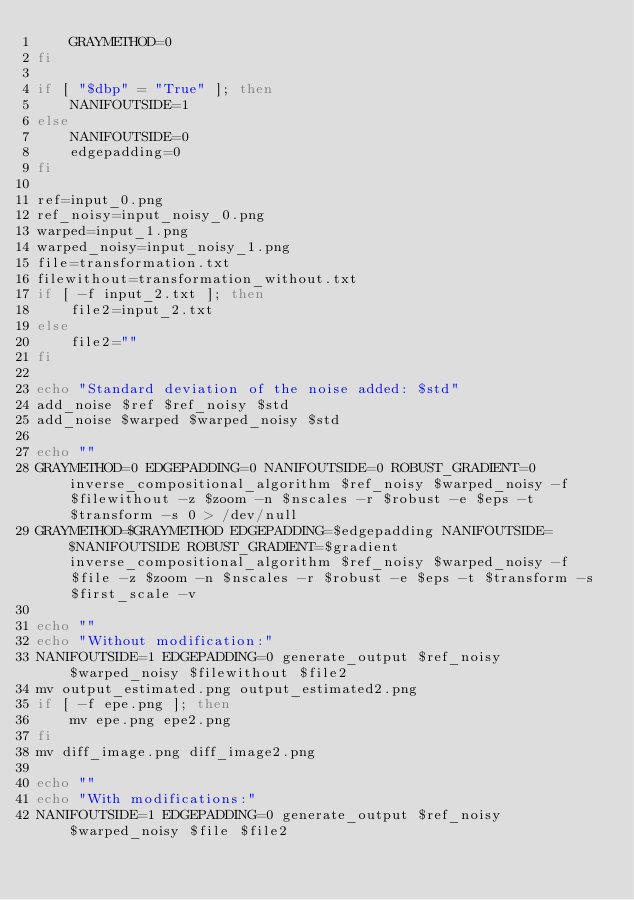Convert code to text. <code><loc_0><loc_0><loc_500><loc_500><_Bash_>    GRAYMETHOD=0
fi

if [ "$dbp" = "True" ]; then
    NANIFOUTSIDE=1
else
    NANIFOUTSIDE=0
    edgepadding=0
fi

ref=input_0.png
ref_noisy=input_noisy_0.png
warped=input_1.png
warped_noisy=input_noisy_1.png
file=transformation.txt
filewithout=transformation_without.txt
if [ -f input_2.txt ]; then
    file2=input_2.txt
else
    file2=""
fi

echo "Standard deviation of the noise added: $std"
add_noise $ref $ref_noisy $std
add_noise $warped $warped_noisy $std

echo ""
GRAYMETHOD=0 EDGEPADDING=0 NANIFOUTSIDE=0 ROBUST_GRADIENT=0 inverse_compositional_algorithm $ref_noisy $warped_noisy -f $filewithout -z $zoom -n $nscales -r $robust -e $eps -t $transform -s 0 > /dev/null
GRAYMETHOD=$GRAYMETHOD EDGEPADDING=$edgepadding NANIFOUTSIDE=$NANIFOUTSIDE ROBUST_GRADIENT=$gradient inverse_compositional_algorithm $ref_noisy $warped_noisy -f $file -z $zoom -n $nscales -r $robust -e $eps -t $transform -s $first_scale -v

echo ""
echo "Without modification:"
NANIFOUTSIDE=1 EDGEPADDING=0 generate_output $ref_noisy $warped_noisy $filewithout $file2
mv output_estimated.png output_estimated2.png
if [ -f epe.png ]; then
    mv epe.png epe2.png
fi
mv diff_image.png diff_image2.png

echo ""
echo "With modifications:"
NANIFOUTSIDE=1 EDGEPADDING=0 generate_output $ref_noisy $warped_noisy $file $file2
</code> 